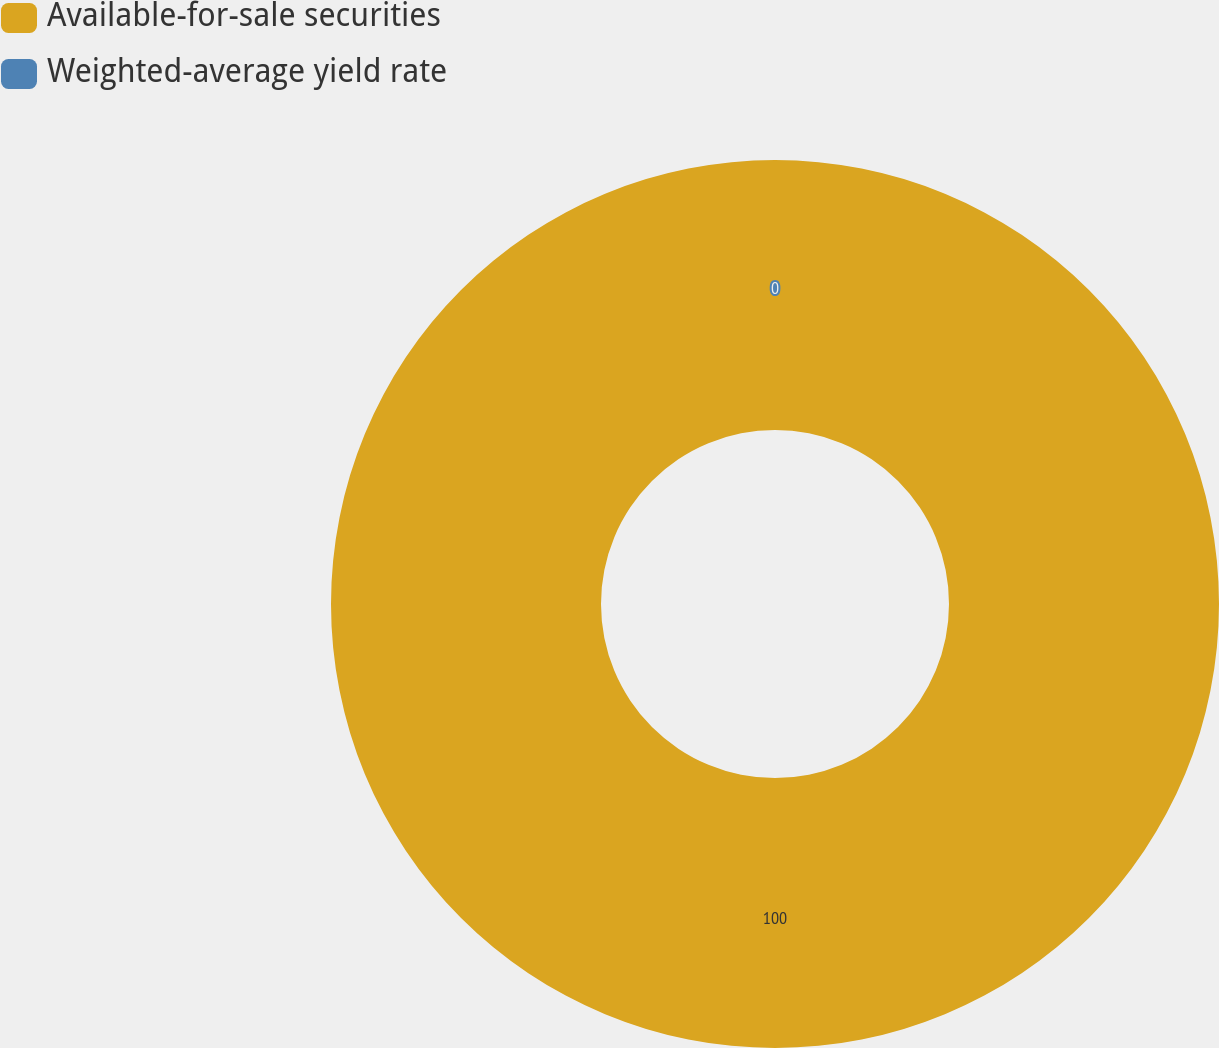<chart> <loc_0><loc_0><loc_500><loc_500><pie_chart><fcel>Available-for-sale securities<fcel>Weighted-average yield rate<nl><fcel>100.0%<fcel>0.0%<nl></chart> 